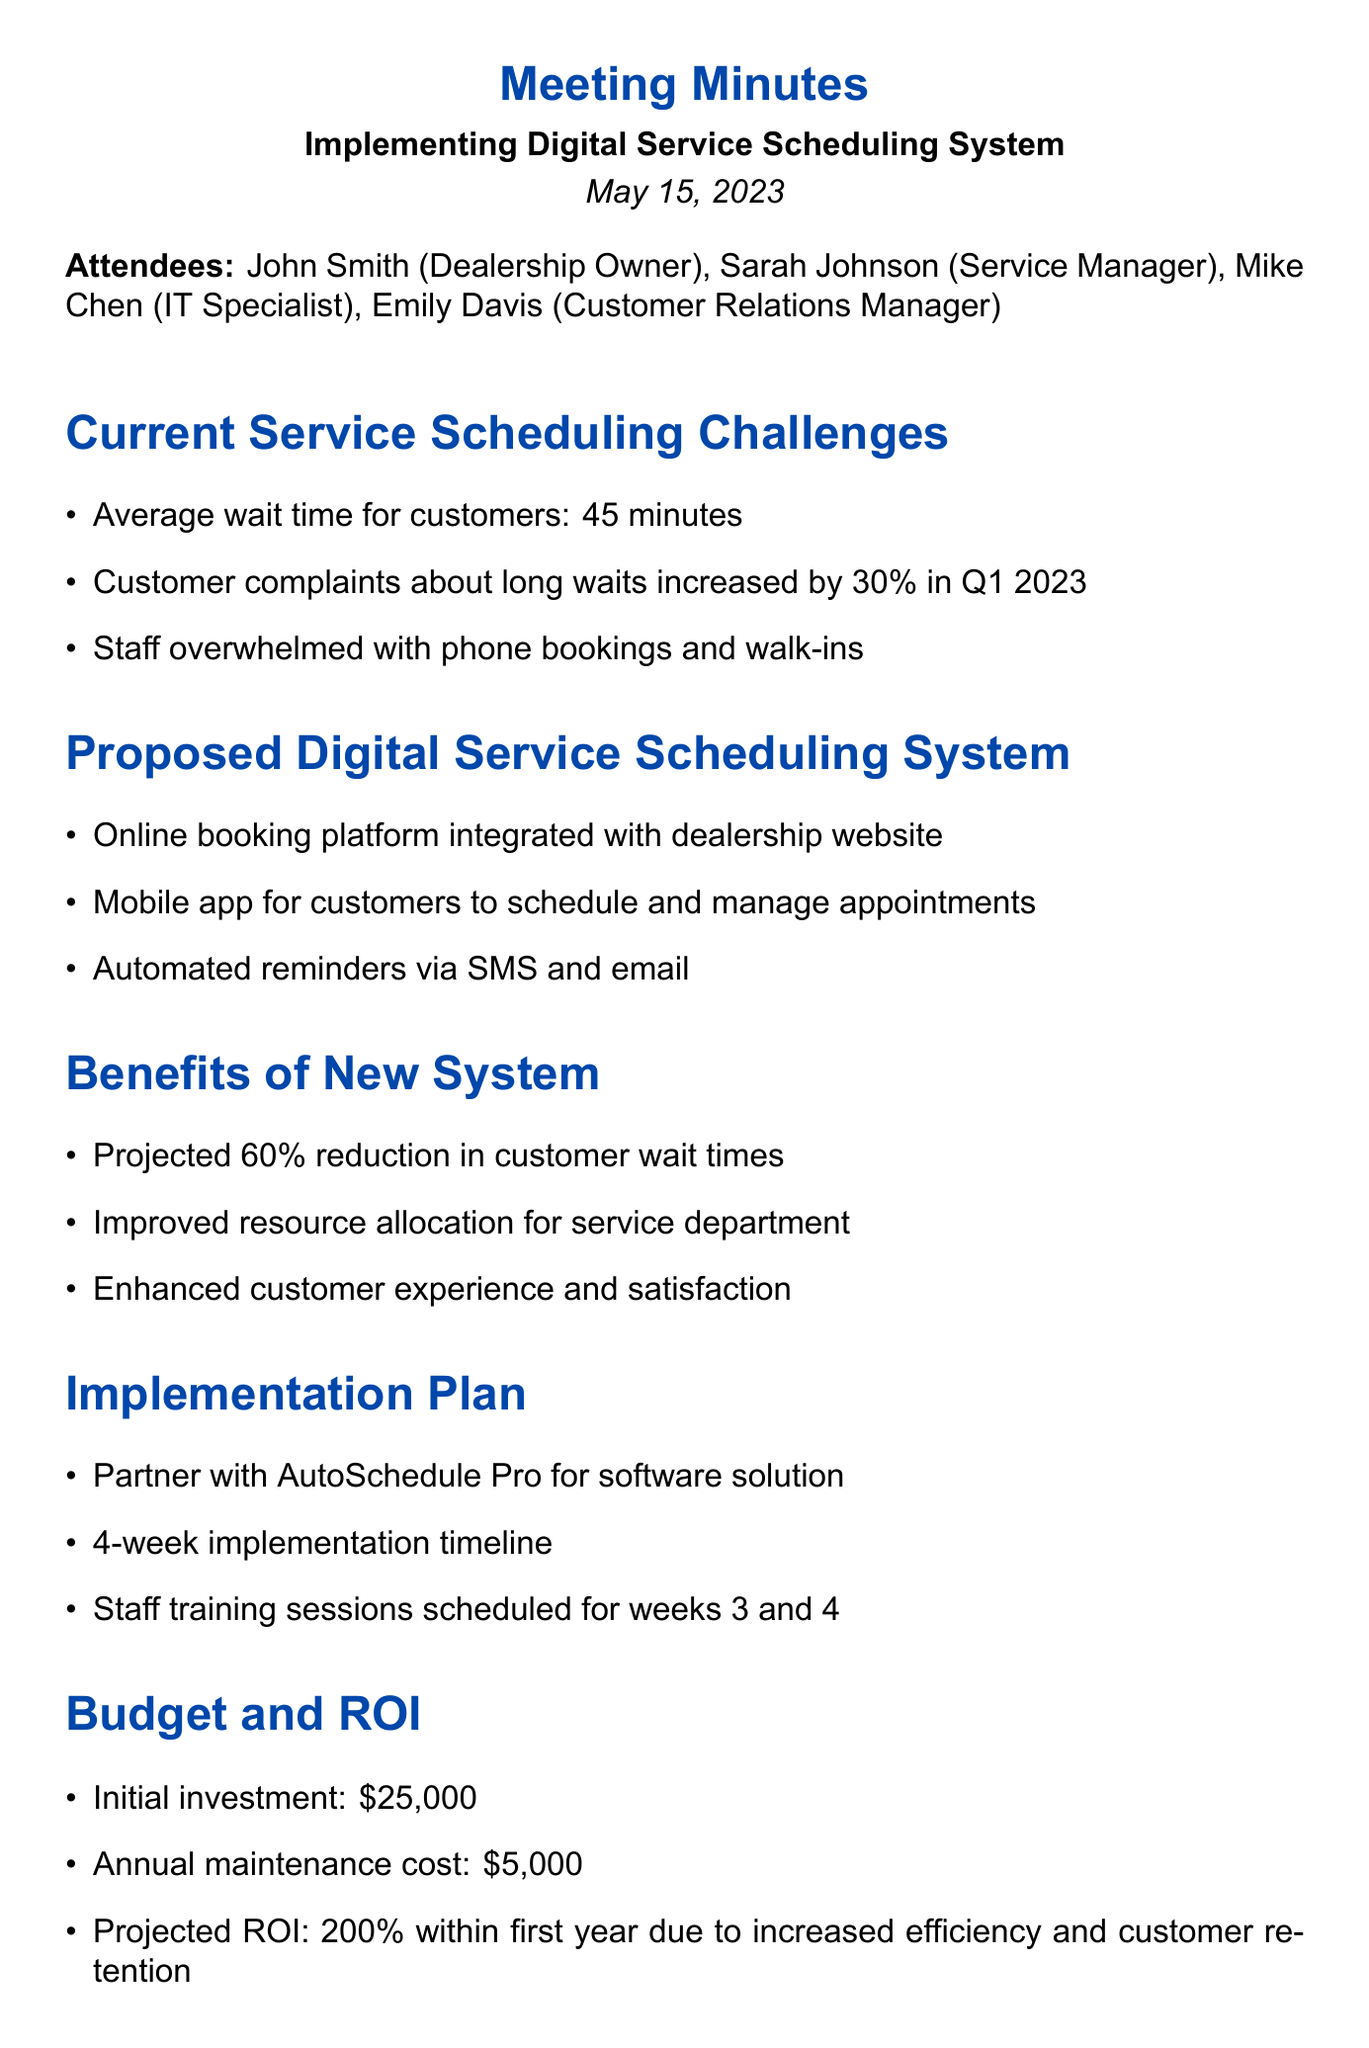What is the average wait time for customers? The average wait time is explicitly stated in the document under the "Current Service Scheduling Challenges" section.
Answer: 45 minutes What percentage of increased customer complaints occurred in Q1 2023? The document specifies the increase in customer complaints during Q1 2023, which is found under the same section.
Answer: 30% Who is the IT Specialist attending the meeting? The document lists attendees, providing specific roles and names.
Answer: Mike Chen What is the projected ROI within the first year? This information is detailed in the "Budget and ROI" section of the document.
Answer: 200% What is the initial investment cost for the new system? The initial investment amount is stated clearly in the "Budget and ROI" section.
Answer: $25,000 When is the system customization scheduled to begin? The timeline for system customization is found in the "Next Steps" section of the document.
Answer: June 1 How long is the implementation timeline? This refers to the expected duration outlined in the "Implementation Plan" section.
Answer: 4 weeks What features are included in the proposed digital service scheduling system? The specifics of the system can be found under the "Proposed Digital Service Scheduling System" heading.
Answer: Online booking platform, mobile app, automated reminders What organization will the dealership partner with for the software solution? The relevant partnership information is included in the "Implementation Plan" section.
Answer: AutoSchedule Pro 